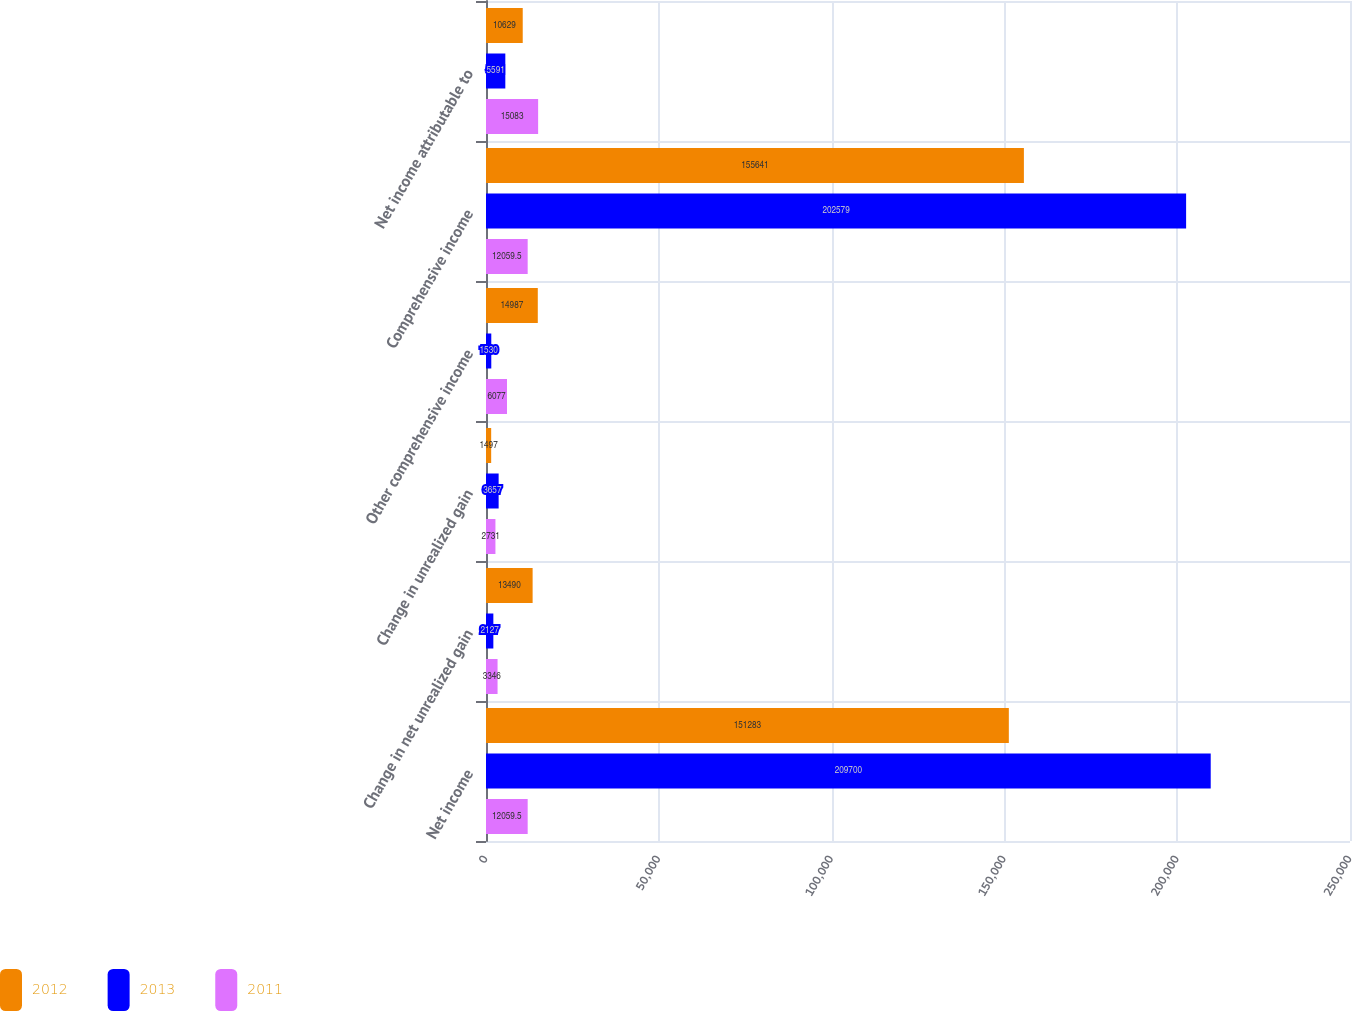Convert chart. <chart><loc_0><loc_0><loc_500><loc_500><stacked_bar_chart><ecel><fcel>Net income<fcel>Change in net unrealized gain<fcel>Change in unrealized gain<fcel>Other comprehensive income<fcel>Comprehensive income<fcel>Net income attributable to<nl><fcel>2012<fcel>151283<fcel>13490<fcel>1497<fcel>14987<fcel>155641<fcel>10629<nl><fcel>2013<fcel>209700<fcel>2127<fcel>3657<fcel>1530<fcel>202579<fcel>5591<nl><fcel>2011<fcel>12059.5<fcel>3346<fcel>2731<fcel>6077<fcel>12059.5<fcel>15083<nl></chart> 